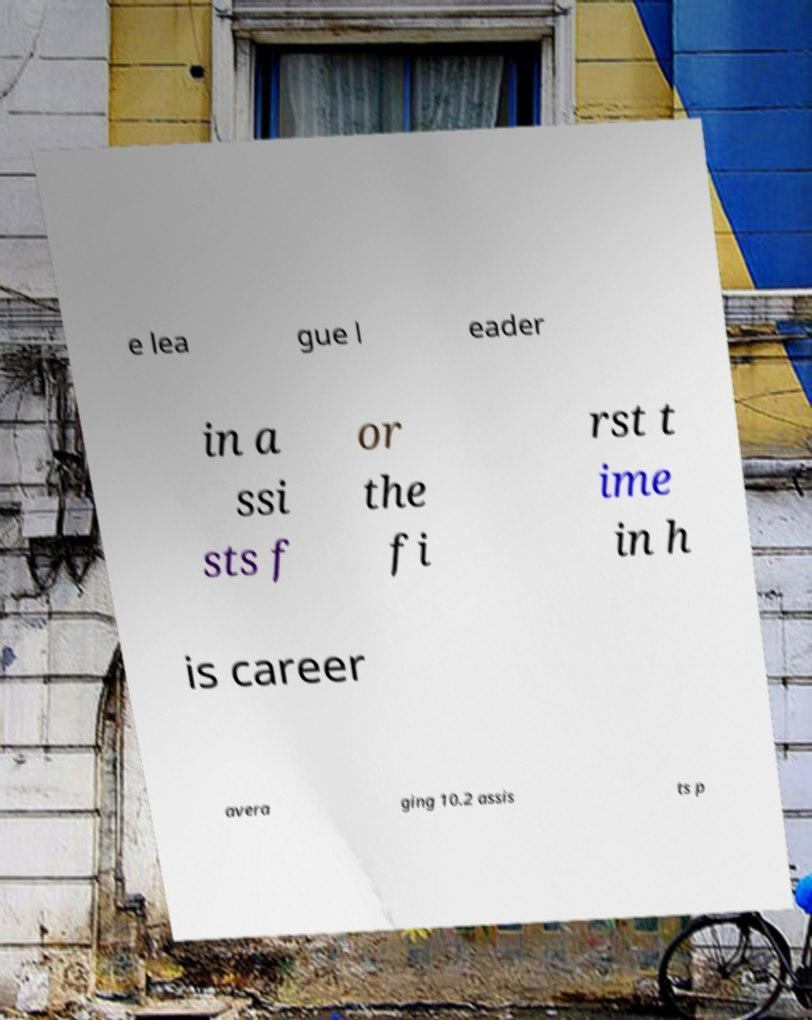Can you accurately transcribe the text from the provided image for me? e lea gue l eader in a ssi sts f or the fi rst t ime in h is career avera ging 10.2 assis ts p 